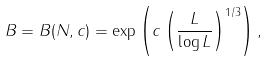<formula> <loc_0><loc_0><loc_500><loc_500>B = B ( N , c ) = \exp \left ( c \left ( \frac { L } { \log L } \right ) ^ { 1 / 3 } \right ) ,</formula> 